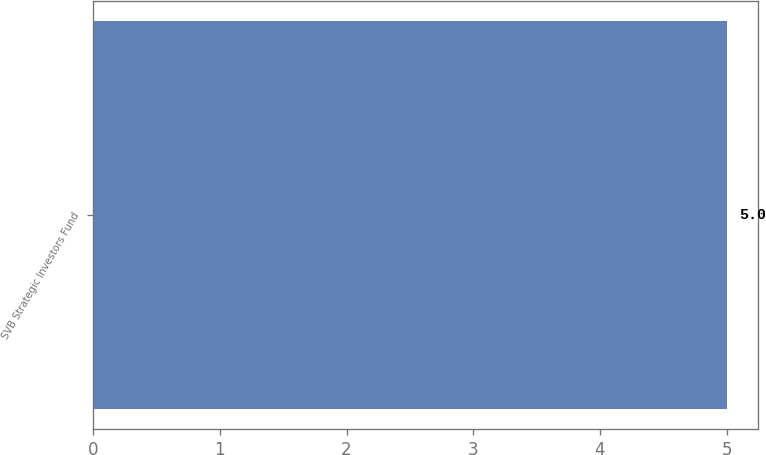<chart> <loc_0><loc_0><loc_500><loc_500><bar_chart><fcel>SVB Strategic Investors Fund<nl><fcel>5<nl></chart> 